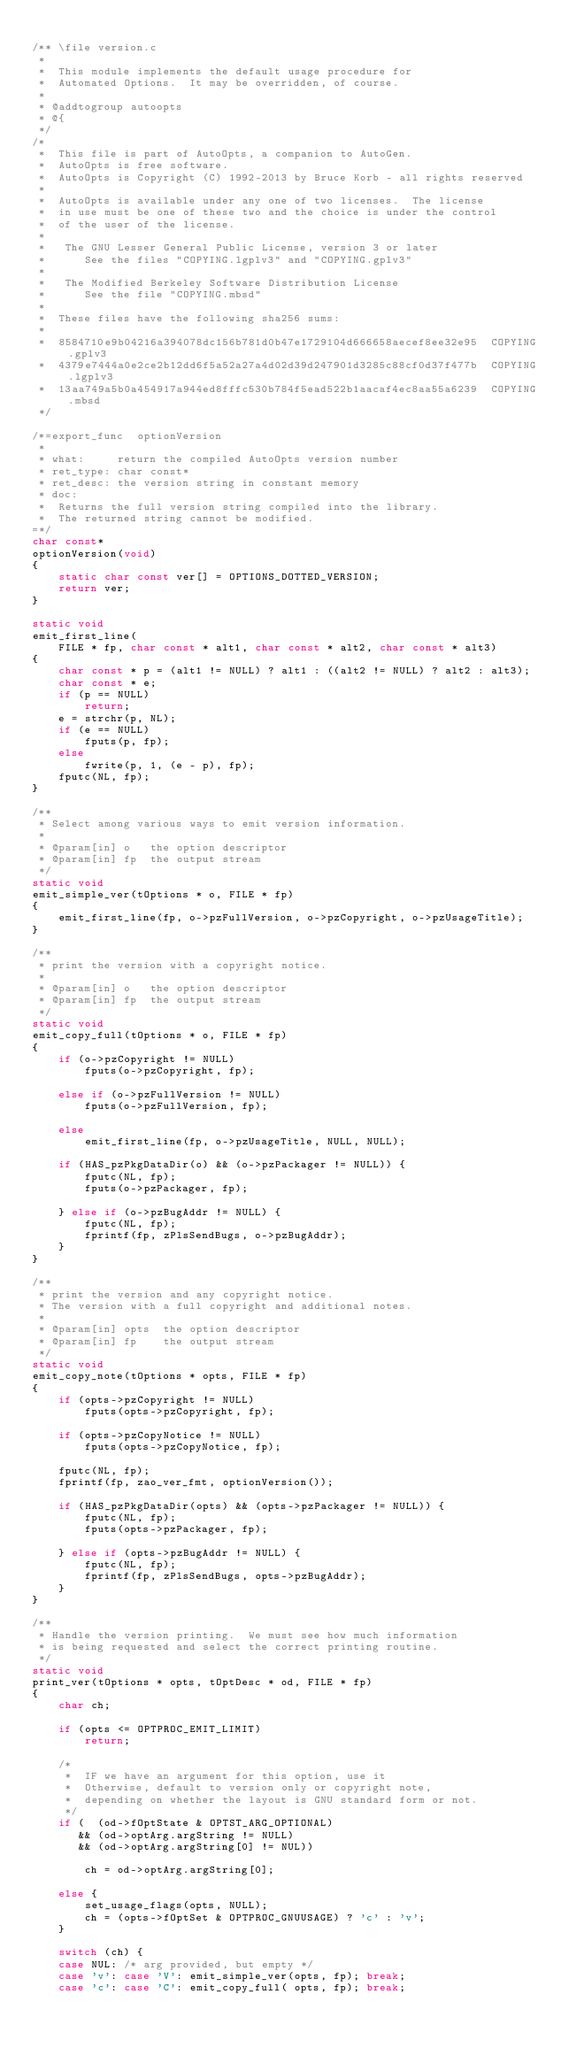Convert code to text. <code><loc_0><loc_0><loc_500><loc_500><_C_>
/** \file version.c
 *
 *  This module implements the default usage procedure for
 *  Automated Options.  It may be overridden, of course.
 *
 * @addtogroup autoopts
 * @{
 */
/*
 *  This file is part of AutoOpts, a companion to AutoGen.
 *  AutoOpts is free software.
 *  AutoOpts is Copyright (C) 1992-2013 by Bruce Korb - all rights reserved
 *
 *  AutoOpts is available under any one of two licenses.  The license
 *  in use must be one of these two and the choice is under the control
 *  of the user of the license.
 *
 *   The GNU Lesser General Public License, version 3 or later
 *      See the files "COPYING.lgplv3" and "COPYING.gplv3"
 *
 *   The Modified Berkeley Software Distribution License
 *      See the file "COPYING.mbsd"
 *
 *  These files have the following sha256 sums:
 *
 *  8584710e9b04216a394078dc156b781d0b47e1729104d666658aecef8ee32e95  COPYING.gplv3
 *  4379e7444a0e2ce2b12dd6f5a52a27a4d02d39d247901d3285c88cf0d37f477b  COPYING.lgplv3
 *  13aa749a5b0a454917a944ed8fffc530b784f5ead522b1aacaf4ec8aa55a6239  COPYING.mbsd
 */

/*=export_func  optionVersion
 *
 * what:     return the compiled AutoOpts version number
 * ret_type: char const*
 * ret_desc: the version string in constant memory
 * doc:
 *  Returns the full version string compiled into the library.
 *  The returned string cannot be modified.
=*/
char const*
optionVersion(void)
{
    static char const ver[] = OPTIONS_DOTTED_VERSION;
    return ver;
}

static void
emit_first_line(
    FILE * fp, char const * alt1, char const * alt2, char const * alt3)
{
    char const * p = (alt1 != NULL) ? alt1 : ((alt2 != NULL) ? alt2 : alt3);
    char const * e;
    if (p == NULL)
        return;
    e = strchr(p, NL);
    if (e == NULL)
        fputs(p, fp);
    else
        fwrite(p, 1, (e - p), fp);
    fputc(NL, fp);
}

/**
 * Select among various ways to emit version information.
 *
 * @param[in] o   the option descriptor
 * @param[in] fp  the output stream
 */
static void
emit_simple_ver(tOptions * o, FILE * fp)
{
    emit_first_line(fp, o->pzFullVersion, o->pzCopyright, o->pzUsageTitle);
}

/**
 * print the version with a copyright notice.
 *
 * @param[in] o   the option descriptor
 * @param[in] fp  the output stream
 */
static void
emit_copy_full(tOptions * o, FILE * fp)
{
    if (o->pzCopyright != NULL)
        fputs(o->pzCopyright, fp);

    else if (o->pzFullVersion != NULL)
        fputs(o->pzFullVersion, fp);

    else
        emit_first_line(fp, o->pzUsageTitle, NULL, NULL);
    
    if (HAS_pzPkgDataDir(o) && (o->pzPackager != NULL)) {
        fputc(NL, fp);
        fputs(o->pzPackager, fp);

    } else if (o->pzBugAddr != NULL) {
        fputc(NL, fp);
        fprintf(fp, zPlsSendBugs, o->pzBugAddr);
    }
}

/**
 * print the version and any copyright notice.
 * The version with a full copyright and additional notes.
 *
 * @param[in] opts  the option descriptor
 * @param[in] fp    the output stream
 */
static void
emit_copy_note(tOptions * opts, FILE * fp)
{
    if (opts->pzCopyright != NULL)
        fputs(opts->pzCopyright, fp);

    if (opts->pzCopyNotice != NULL)
        fputs(opts->pzCopyNotice, fp);

    fputc(NL, fp);
    fprintf(fp, zao_ver_fmt, optionVersion());
    
    if (HAS_pzPkgDataDir(opts) && (opts->pzPackager != NULL)) {
        fputc(NL, fp);
        fputs(opts->pzPackager, fp);

    } else if (opts->pzBugAddr != NULL) {
        fputc(NL, fp);
        fprintf(fp, zPlsSendBugs, opts->pzBugAddr);
    }
}

/**
 * Handle the version printing.  We must see how much information
 * is being requested and select the correct printing routine.
 */
static void
print_ver(tOptions * opts, tOptDesc * od, FILE * fp)
{
    char ch;

    if (opts <= OPTPROC_EMIT_LIMIT)
        return;

    /*
     *  IF we have an argument for this option, use it
     *  Otherwise, default to version only or copyright note,
     *  depending on whether the layout is GNU standard form or not.
     */
    if (  (od->fOptState & OPTST_ARG_OPTIONAL)
       && (od->optArg.argString != NULL)
       && (od->optArg.argString[0] != NUL))

        ch = od->optArg.argString[0];

    else {
        set_usage_flags(opts, NULL);
        ch = (opts->fOptSet & OPTPROC_GNUUSAGE) ? 'c' : 'v';
    }

    switch (ch) {
    case NUL: /* arg provided, but empty */
    case 'v': case 'V': emit_simple_ver(opts, fp); break;
    case 'c': case 'C': emit_copy_full( opts, fp); break;</code> 